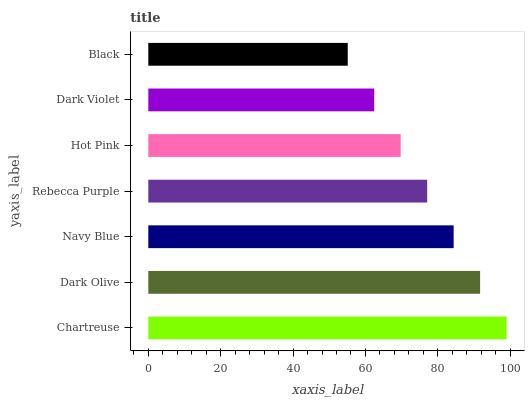Is Black the minimum?
Answer yes or no. Yes. Is Chartreuse the maximum?
Answer yes or no. Yes. Is Dark Olive the minimum?
Answer yes or no. No. Is Dark Olive the maximum?
Answer yes or no. No. Is Chartreuse greater than Dark Olive?
Answer yes or no. Yes. Is Dark Olive less than Chartreuse?
Answer yes or no. Yes. Is Dark Olive greater than Chartreuse?
Answer yes or no. No. Is Chartreuse less than Dark Olive?
Answer yes or no. No. Is Rebecca Purple the high median?
Answer yes or no. Yes. Is Rebecca Purple the low median?
Answer yes or no. Yes. Is Hot Pink the high median?
Answer yes or no. No. Is Chartreuse the low median?
Answer yes or no. No. 